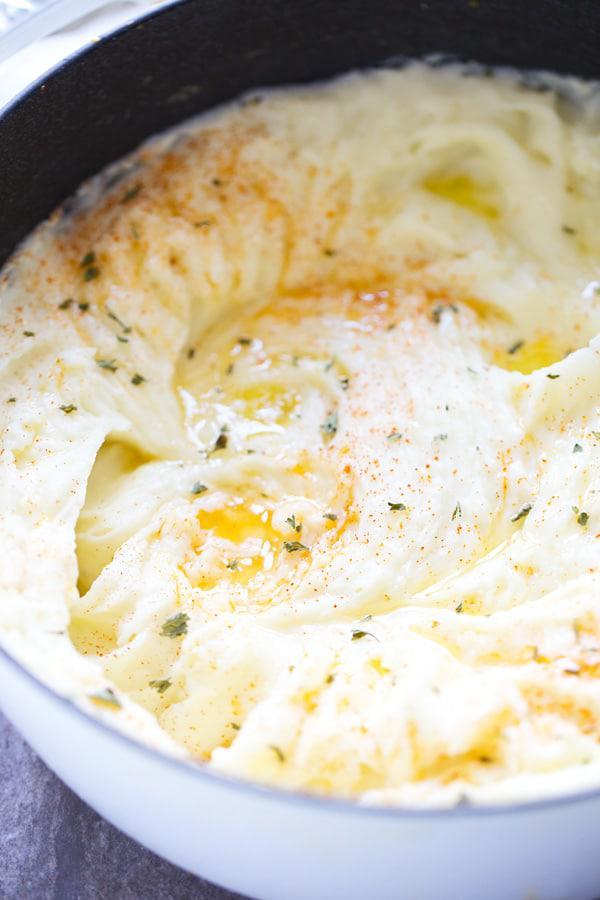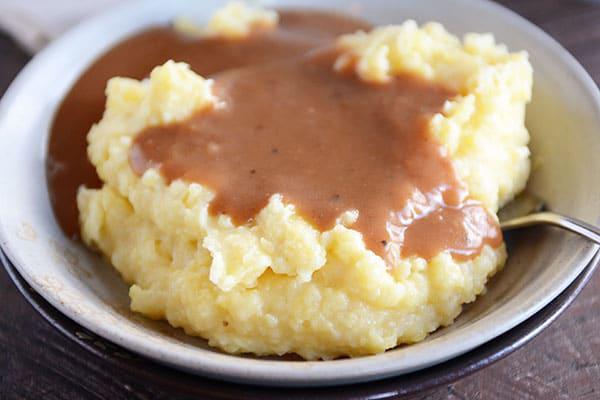The first image is the image on the left, the second image is the image on the right. Examine the images to the left and right. Is the description "A eating utensil is visible in the right image." accurate? Answer yes or no. Yes. The first image is the image on the left, the second image is the image on the right. Examine the images to the left and right. Is the description "One bowl of mashed potatoes has visible pools of melted butter, and the other does not." accurate? Answer yes or no. No. The first image is the image on the left, the second image is the image on the right. Analyze the images presented: Is the assertion "One image shows a round bowl of mashed potatoes with the handle of a piece of silverware sticking out of it." valid? Answer yes or no. Yes. The first image is the image on the left, the second image is the image on the right. For the images displayed, is the sentence "The left and right image contains the same number of round bowls holding mash potatoes." factually correct? Answer yes or no. Yes. 